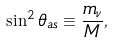<formula> <loc_0><loc_0><loc_500><loc_500>\sin ^ { 2 } \theta _ { a s } \equiv \frac { m _ { \nu } } { M } ,</formula> 